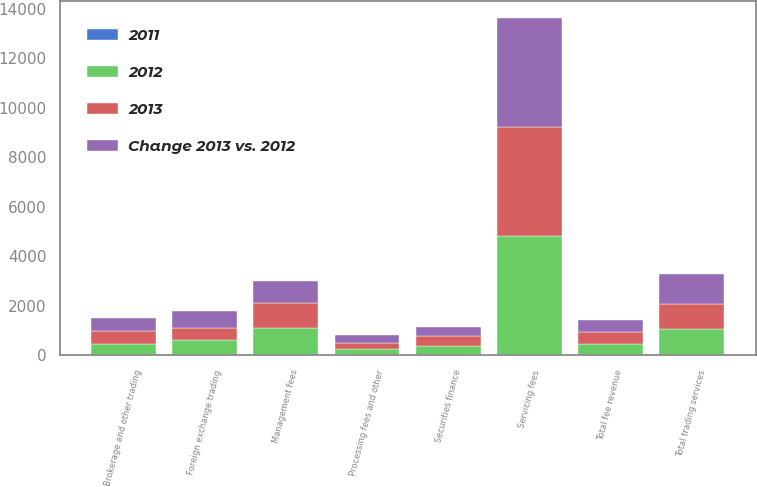<chart> <loc_0><loc_0><loc_500><loc_500><stacked_bar_chart><ecel><fcel>Servicing fees<fcel>Management fees<fcel>Foreign exchange trading<fcel>Brokerage and other trading<fcel>Total trading services<fcel>Securities finance<fcel>Processing fees and other<fcel>Total fee revenue<nl><fcel>2012<fcel>4819<fcel>1106<fcel>589<fcel>472<fcel>1061<fcel>359<fcel>245<fcel>472<nl><fcel>2013<fcel>4414<fcel>993<fcel>511<fcel>499<fcel>1010<fcel>405<fcel>266<fcel>472<nl><fcel>Change 2013 vs. 2012<fcel>4382<fcel>917<fcel>683<fcel>537<fcel>1220<fcel>378<fcel>297<fcel>472<nl><fcel>2011<fcel>9<fcel>11<fcel>15<fcel>5<fcel>5<fcel>11<fcel>8<fcel>7<nl></chart> 